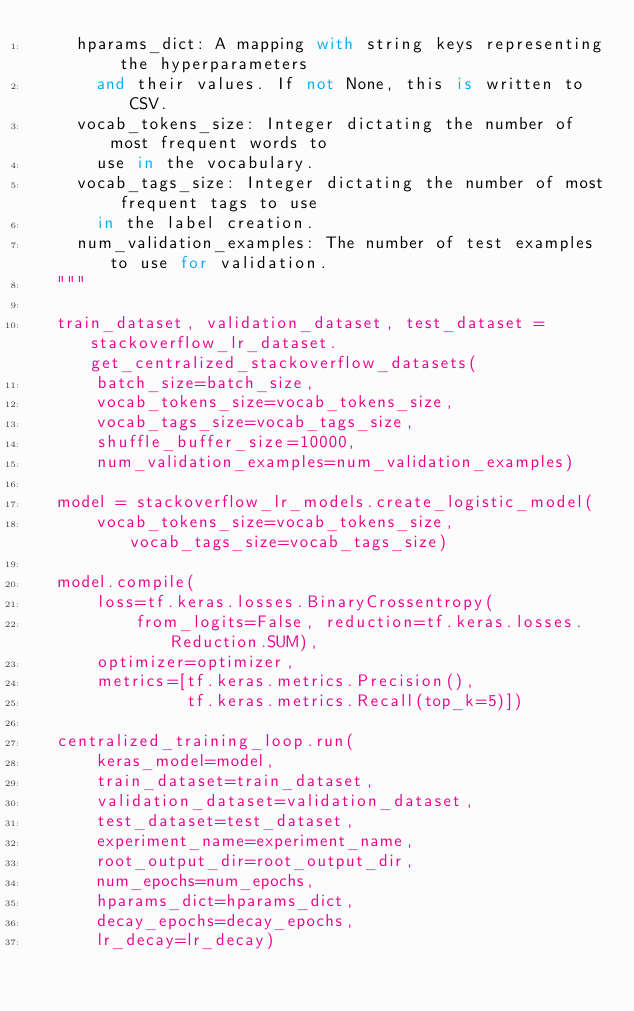<code> <loc_0><loc_0><loc_500><loc_500><_Python_>    hparams_dict: A mapping with string keys representing the hyperparameters
      and their values. If not None, this is written to CSV.
    vocab_tokens_size: Integer dictating the number of most frequent words to
      use in the vocabulary.
    vocab_tags_size: Integer dictating the number of most frequent tags to use
      in the label creation.
    num_validation_examples: The number of test examples to use for validation.
  """

  train_dataset, validation_dataset, test_dataset = stackoverflow_lr_dataset.get_centralized_stackoverflow_datasets(
      batch_size=batch_size,
      vocab_tokens_size=vocab_tokens_size,
      vocab_tags_size=vocab_tags_size,
      shuffle_buffer_size=10000,
      num_validation_examples=num_validation_examples)

  model = stackoverflow_lr_models.create_logistic_model(
      vocab_tokens_size=vocab_tokens_size, vocab_tags_size=vocab_tags_size)

  model.compile(
      loss=tf.keras.losses.BinaryCrossentropy(
          from_logits=False, reduction=tf.keras.losses.Reduction.SUM),
      optimizer=optimizer,
      metrics=[tf.keras.metrics.Precision(),
               tf.keras.metrics.Recall(top_k=5)])

  centralized_training_loop.run(
      keras_model=model,
      train_dataset=train_dataset,
      validation_dataset=validation_dataset,
      test_dataset=test_dataset,
      experiment_name=experiment_name,
      root_output_dir=root_output_dir,
      num_epochs=num_epochs,
      hparams_dict=hparams_dict,
      decay_epochs=decay_epochs,
      lr_decay=lr_decay)
</code> 